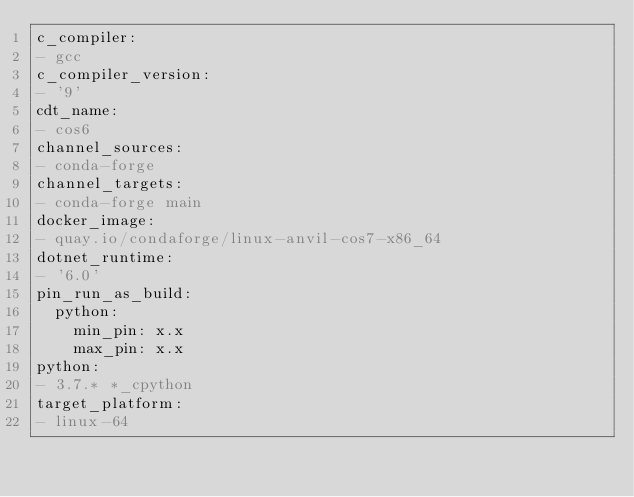Convert code to text. <code><loc_0><loc_0><loc_500><loc_500><_YAML_>c_compiler:
- gcc
c_compiler_version:
- '9'
cdt_name:
- cos6
channel_sources:
- conda-forge
channel_targets:
- conda-forge main
docker_image:
- quay.io/condaforge/linux-anvil-cos7-x86_64
dotnet_runtime:
- '6.0'
pin_run_as_build:
  python:
    min_pin: x.x
    max_pin: x.x
python:
- 3.7.* *_cpython
target_platform:
- linux-64
</code> 